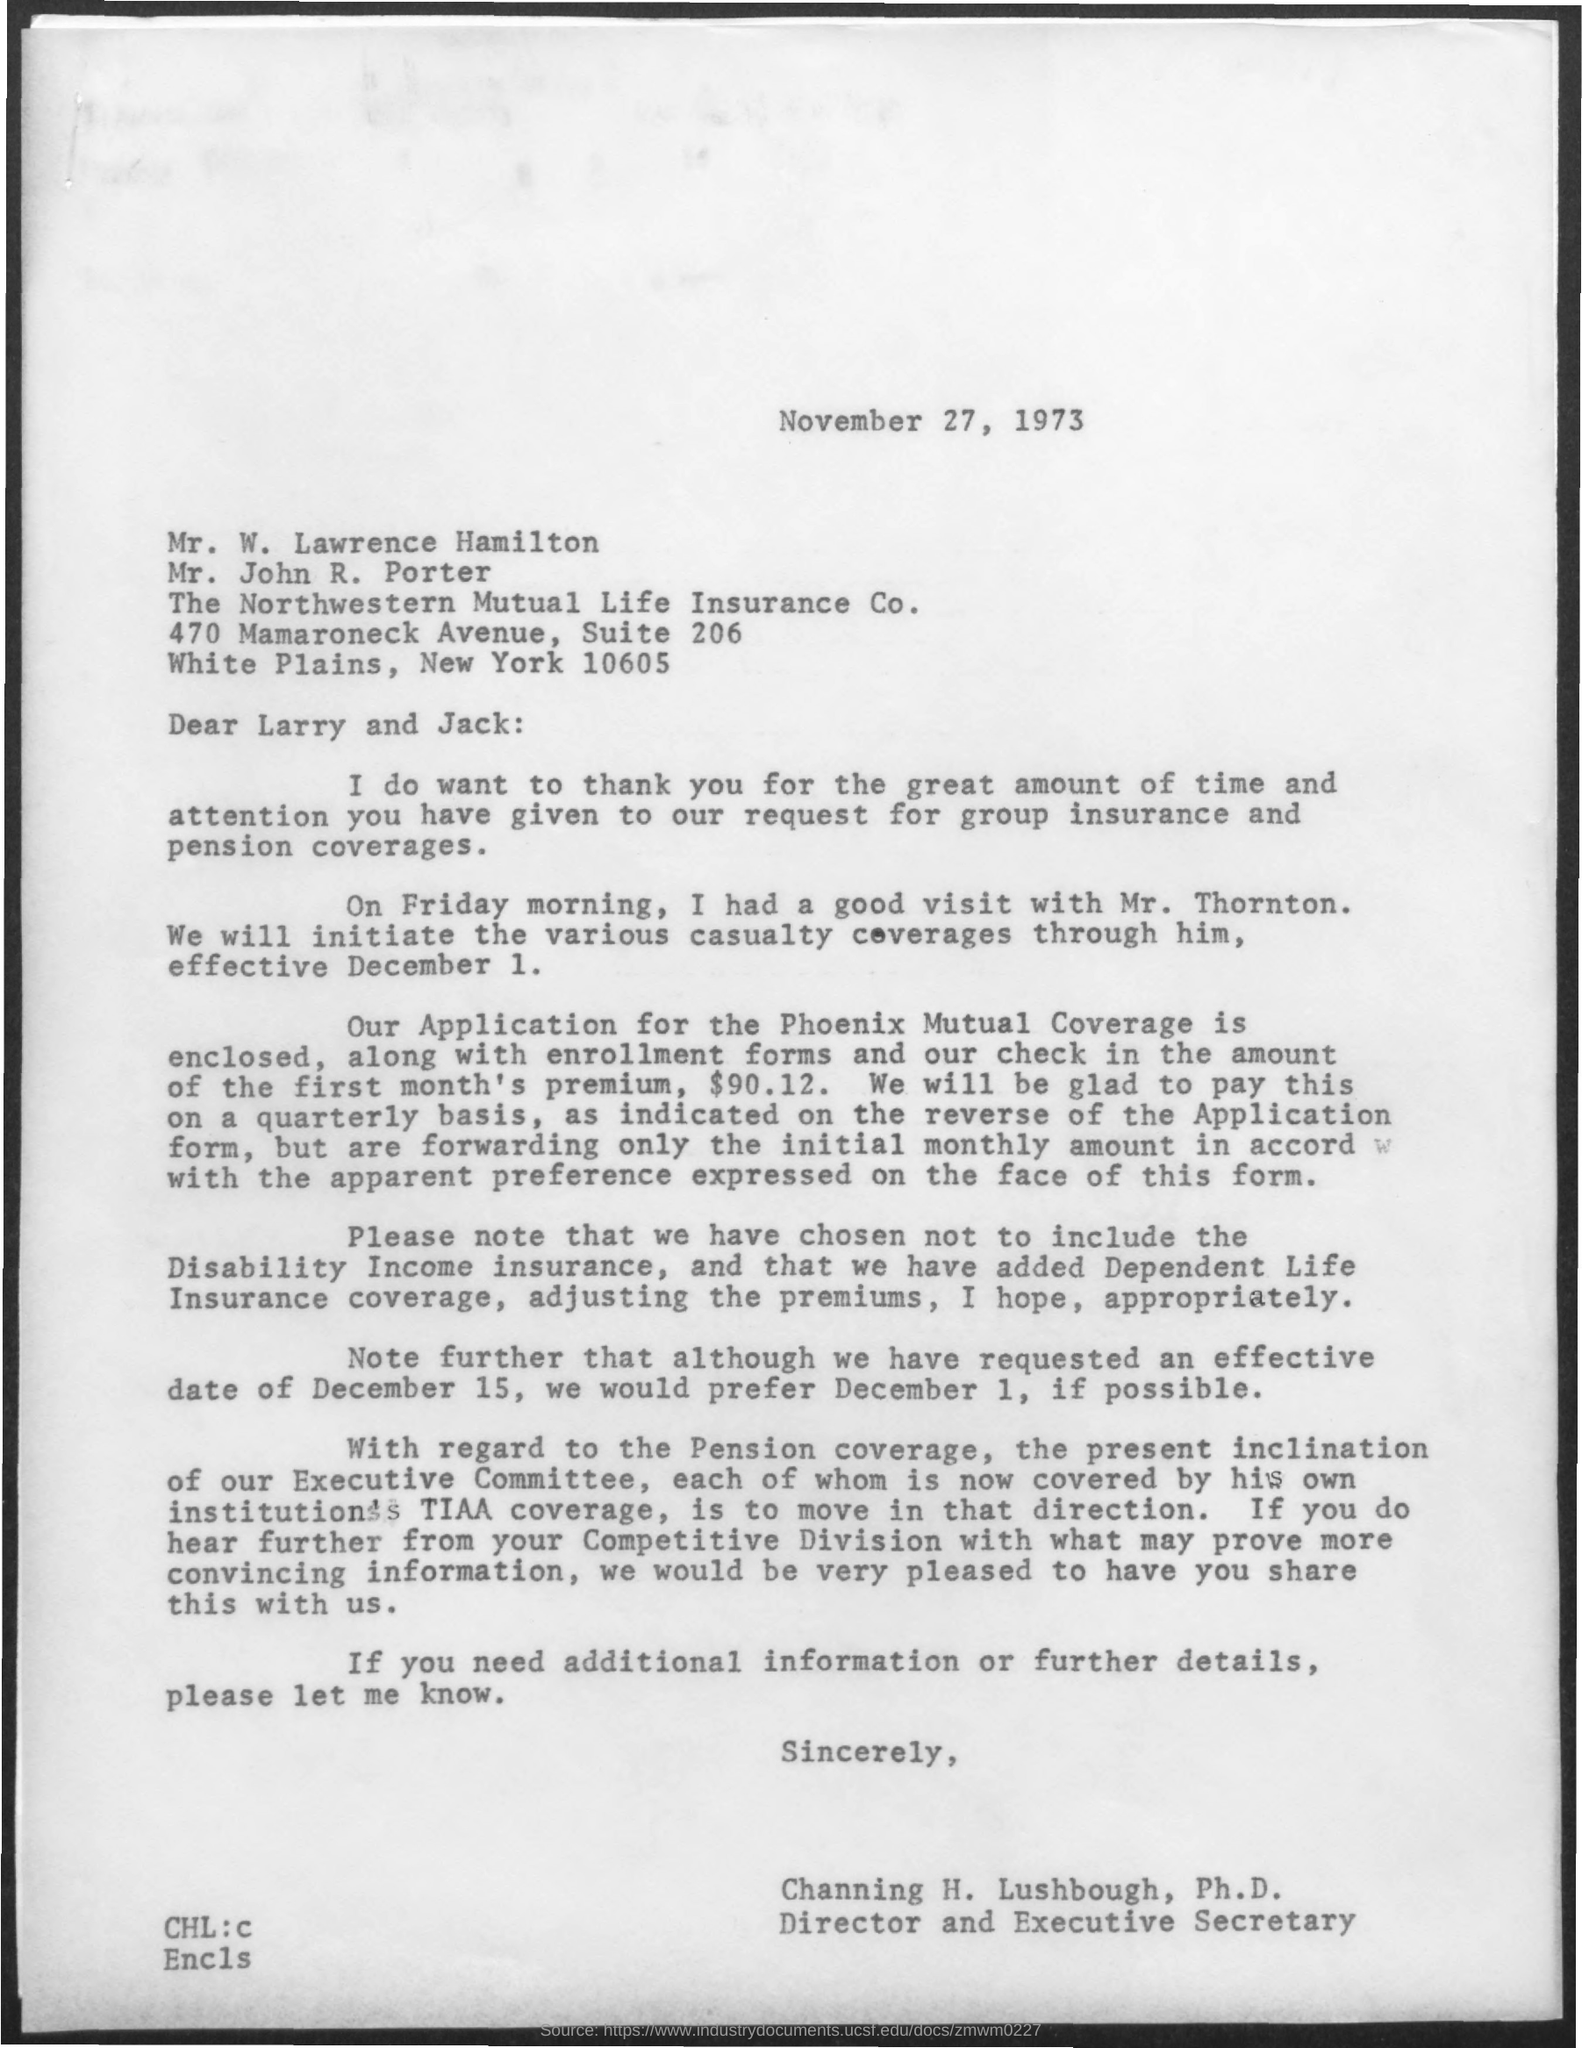What is the date mentioned in the given letter ?
Ensure brevity in your answer.  November 27, 1973. To whom this letter was written ?
Offer a very short reply. Larry and Jack. To which company lawrence hamilton and porter belongs to ?
Offer a terse response. The Northwestern Mutual Life Insurance Co. What is the designation of channing h. lushbough ?
Give a very brief answer. Director and executive secretary. 